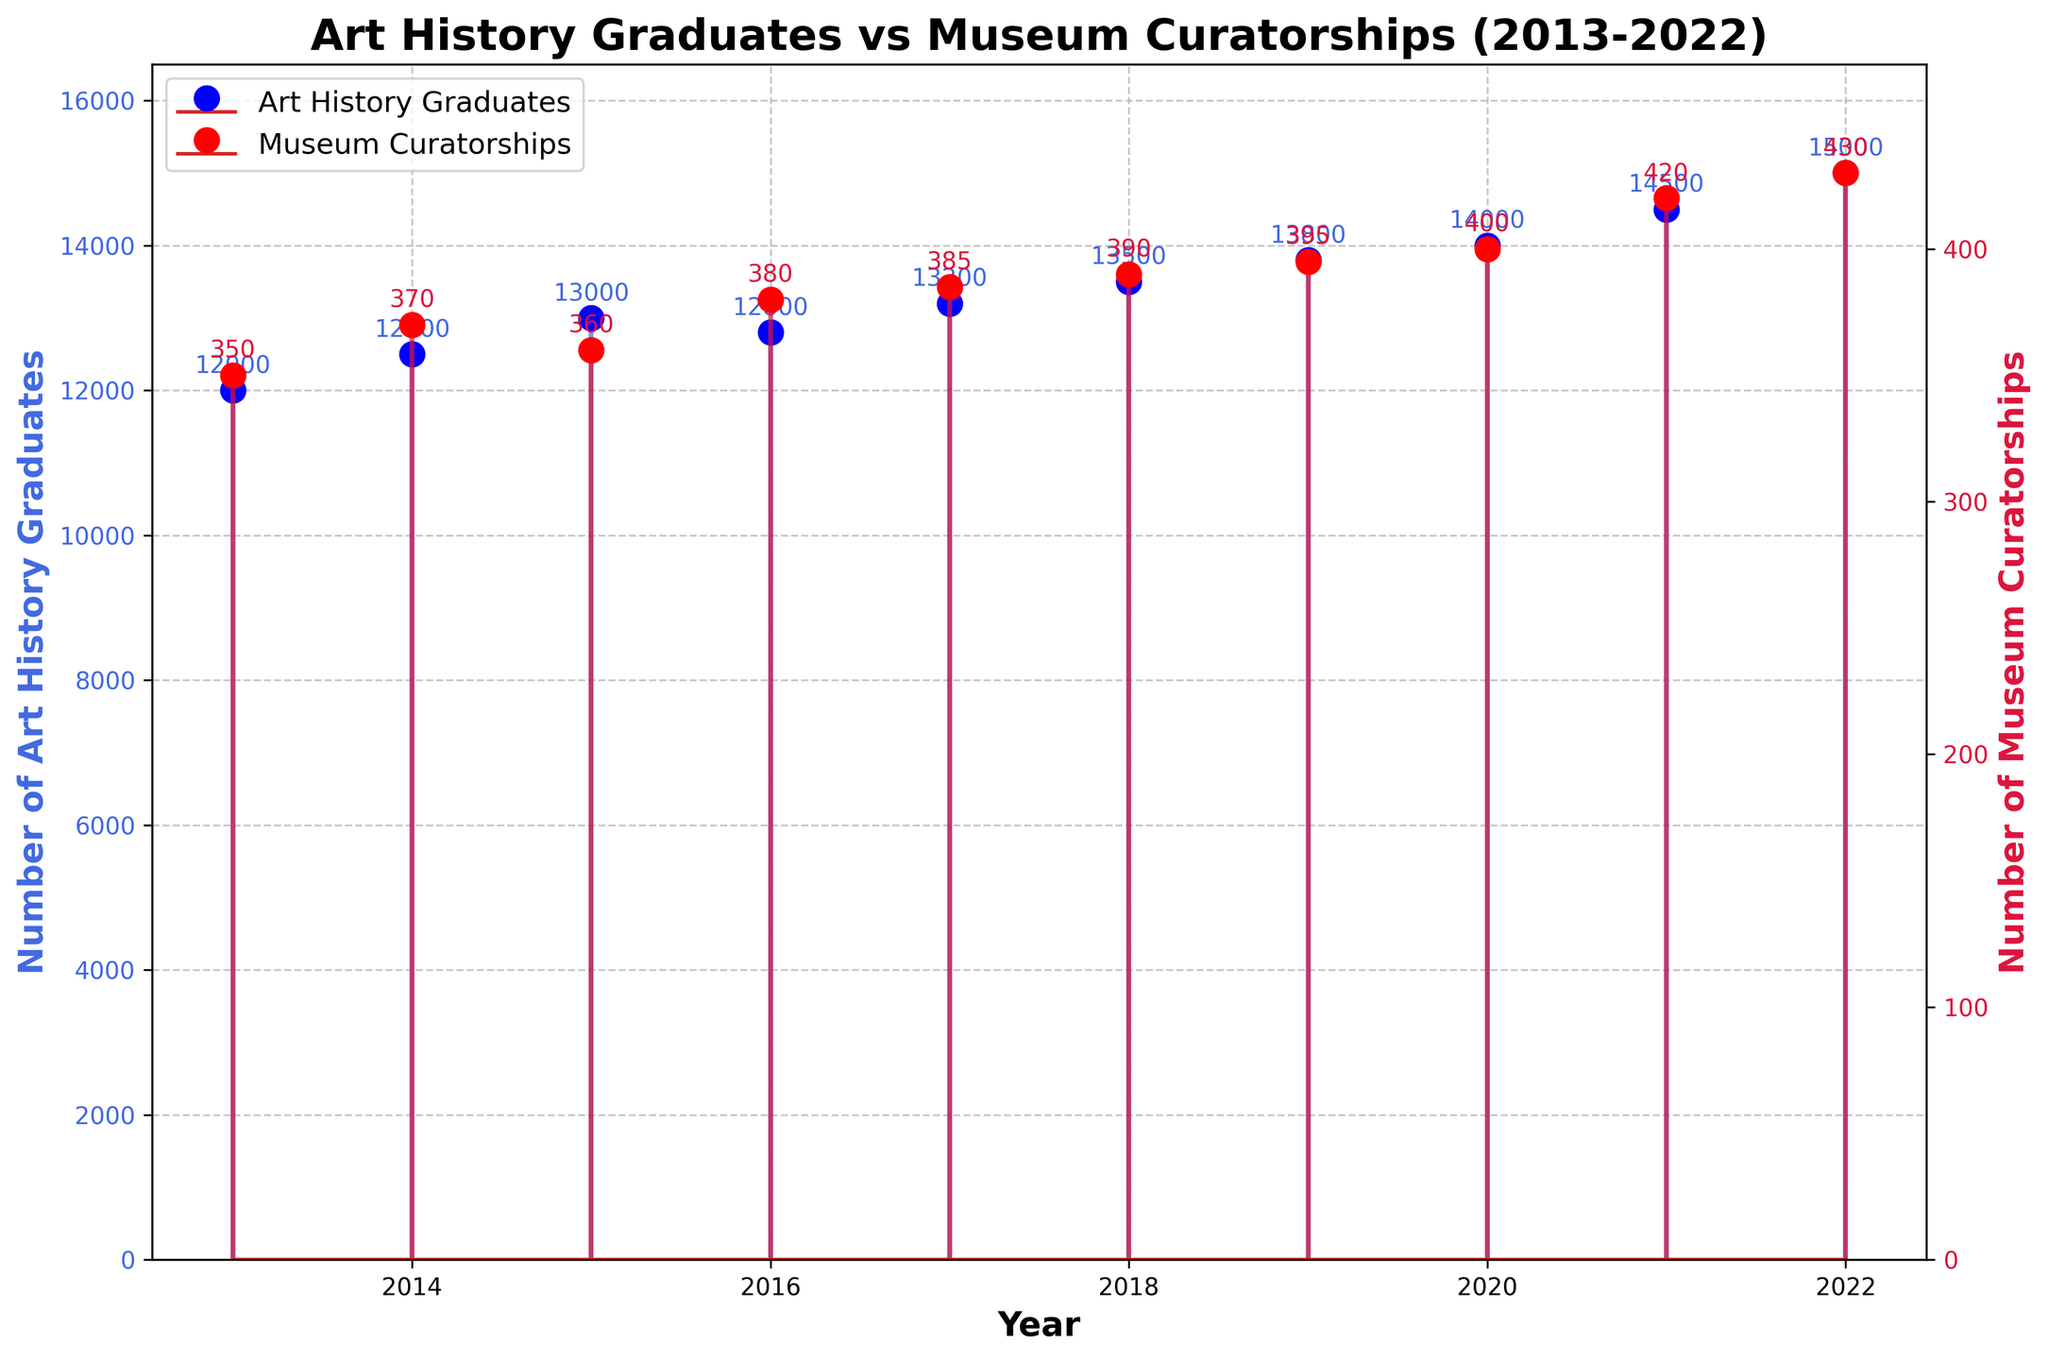What's the title of the figure? The title is located at the top of the figure in bold text which is usually the most significant element that describes the overall content of the figure.
Answer: Art History Graduates vs Museum Curatorships (2013-2022) What do the colors red and blue represent in the figure? The legend indicates that the red color represents 'Museum Curatorships', and the blue color represents 'Art History Graduates.'
Answer: Red represents Museum Curatorships, and blue represents Art History Graduates How many years are covered in the figure? The x-axis denotes the years and ranges from 2013 to 2022. Counting all the individual tick marks for each year in this range gives us a total of 10 years.
Answer: 10 years In which year was the number of Art History Graduates the highest? By examining the blue markers in the figure, the highest data point on the y-axis corresponds to the year 2022. Additionally, checking the annotations confirms that number as 15,000.
Answer: 2022 In which year was the number of Museum Curatorships the lowest? By analyzing the red markers, the lowest data point corresponds to the year 2013, with the annotation indicating the number 350.
Answer: 2013 What are the y-axis values for Art History Graduates and Museum Curatorships in 2020? The annotated values for the year 2020 indicate the data. The blue annotation is 14,000 for Art History Graduates, and the red annotation is 400 for Museum Curatorships.
Answer: 14,000 graduates and 400 curatorships What's the average number of Art History Graduates from 2013 to 2022? Sum all Art History Graduates numbers: 12000 + 12500 + 13000 + 12800 + 13200 + 13500 + 13800 + 14000 + 14500 + 15000 = 133300. Divide this sum by the number of years (10) to get the average: 133300 / 10 = 13330.
Answer: 13,330 Between 2016 and 2022, in which year did the number of Museum Curatorships increase the most compared to the previous year? The increase for each year is as follows: 
2017: 385 - 380 = 5 
2018: 390 - 385 = 5 
2019: 395 - 390 = 5 
2020: 400 - 395 = 5 
2021: 420 - 400 = 20 
2022: 430 - 420 = 10
The year with the highest increase is 2021, with an increase of 20.
Answer: 2021 What's the difference in the number of Art History Graduates between 2017 and 2022? The number of Art History Graduates in 2017 was 13,200, and in 2022 it was 15,000. The difference is 15,000 - 13,200 = 1,800.
Answer: 1,800 On average, how many Museum Curatorships were added per year from 2013 to 2022? To find the average annual increase in Museum Curatorships:
1. Calculate the total change in curatorships: 430 (2022) - 350 (2013) = 80.
2. Divide by the number of years: 80 / 10 = 8.
Answer: 8 per year 